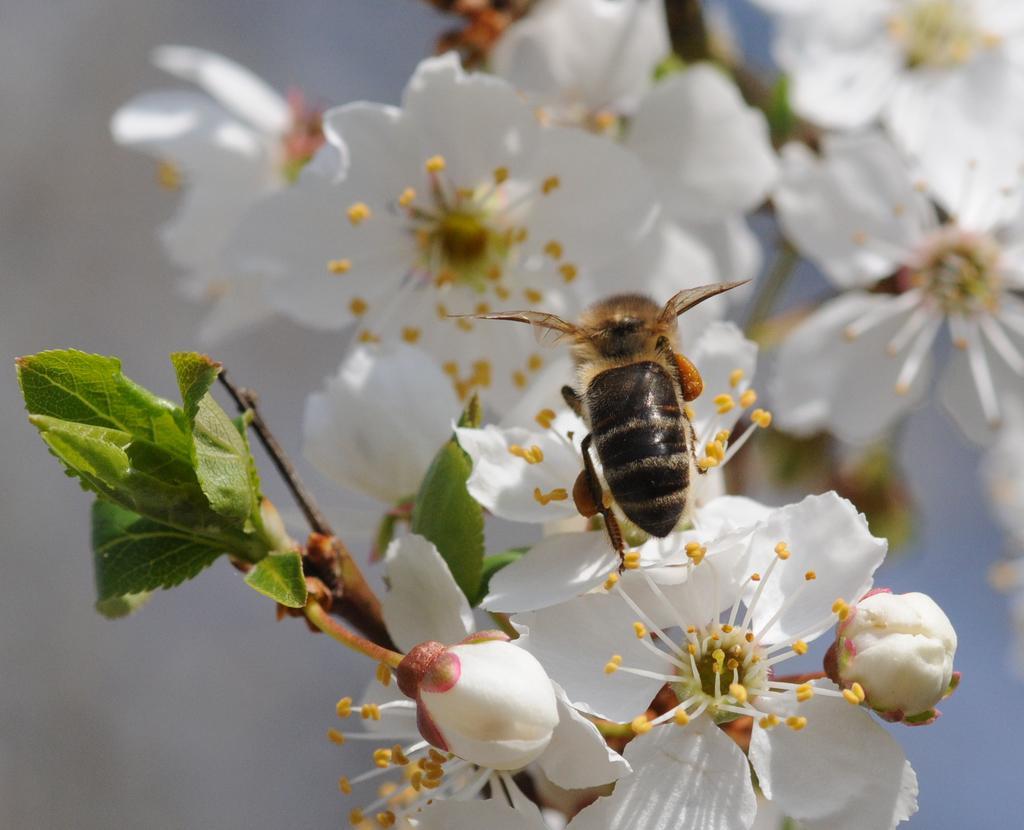Can you describe this image briefly? In this image, on the right side, we can see a insect which is on the flower and the flower is in white color. On the left side, we can see green leaves. 